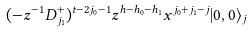<formula> <loc_0><loc_0><loc_500><loc_500>( - z ^ { - 1 } D _ { j _ { 1 } } ^ { + } ) ^ { t - 2 j _ { 0 } - 1 } z ^ { h - h _ { 0 } - h _ { 1 } } x ^ { j _ { 0 } + j _ { 1 } - j } | 0 , 0 \rangle _ { j }</formula> 